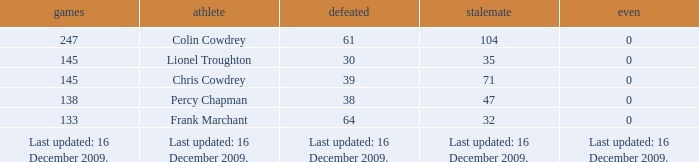Name the tie that has 71 drawn 0.0. 